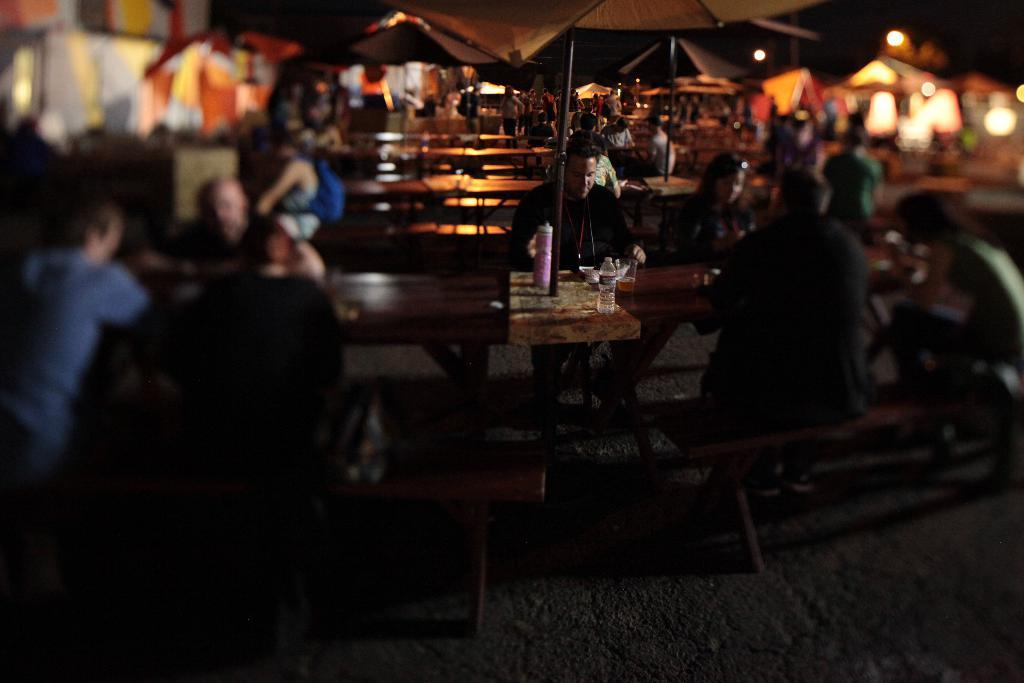What are the people in the image doing? The people in the image are sitting on benches. What else can be seen in the image besides the people? There is a table in the image. What is on the table? There is a bottle on the table. What is the color of the floor in the image? The floor is in brown color. Can you tell me how many kites are being flown by the people in the image? There are no kites visible in the image; the people are sitting on benches and there is a table with a bottle on it. 